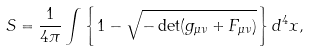Convert formula to latex. <formula><loc_0><loc_0><loc_500><loc_500>S = \frac { 1 } { 4 \pi } \int \left \{ 1 - \sqrt { - \det ( g _ { \mu \nu } + F _ { \mu \nu } ) } \right \} d ^ { 4 } x ,</formula> 